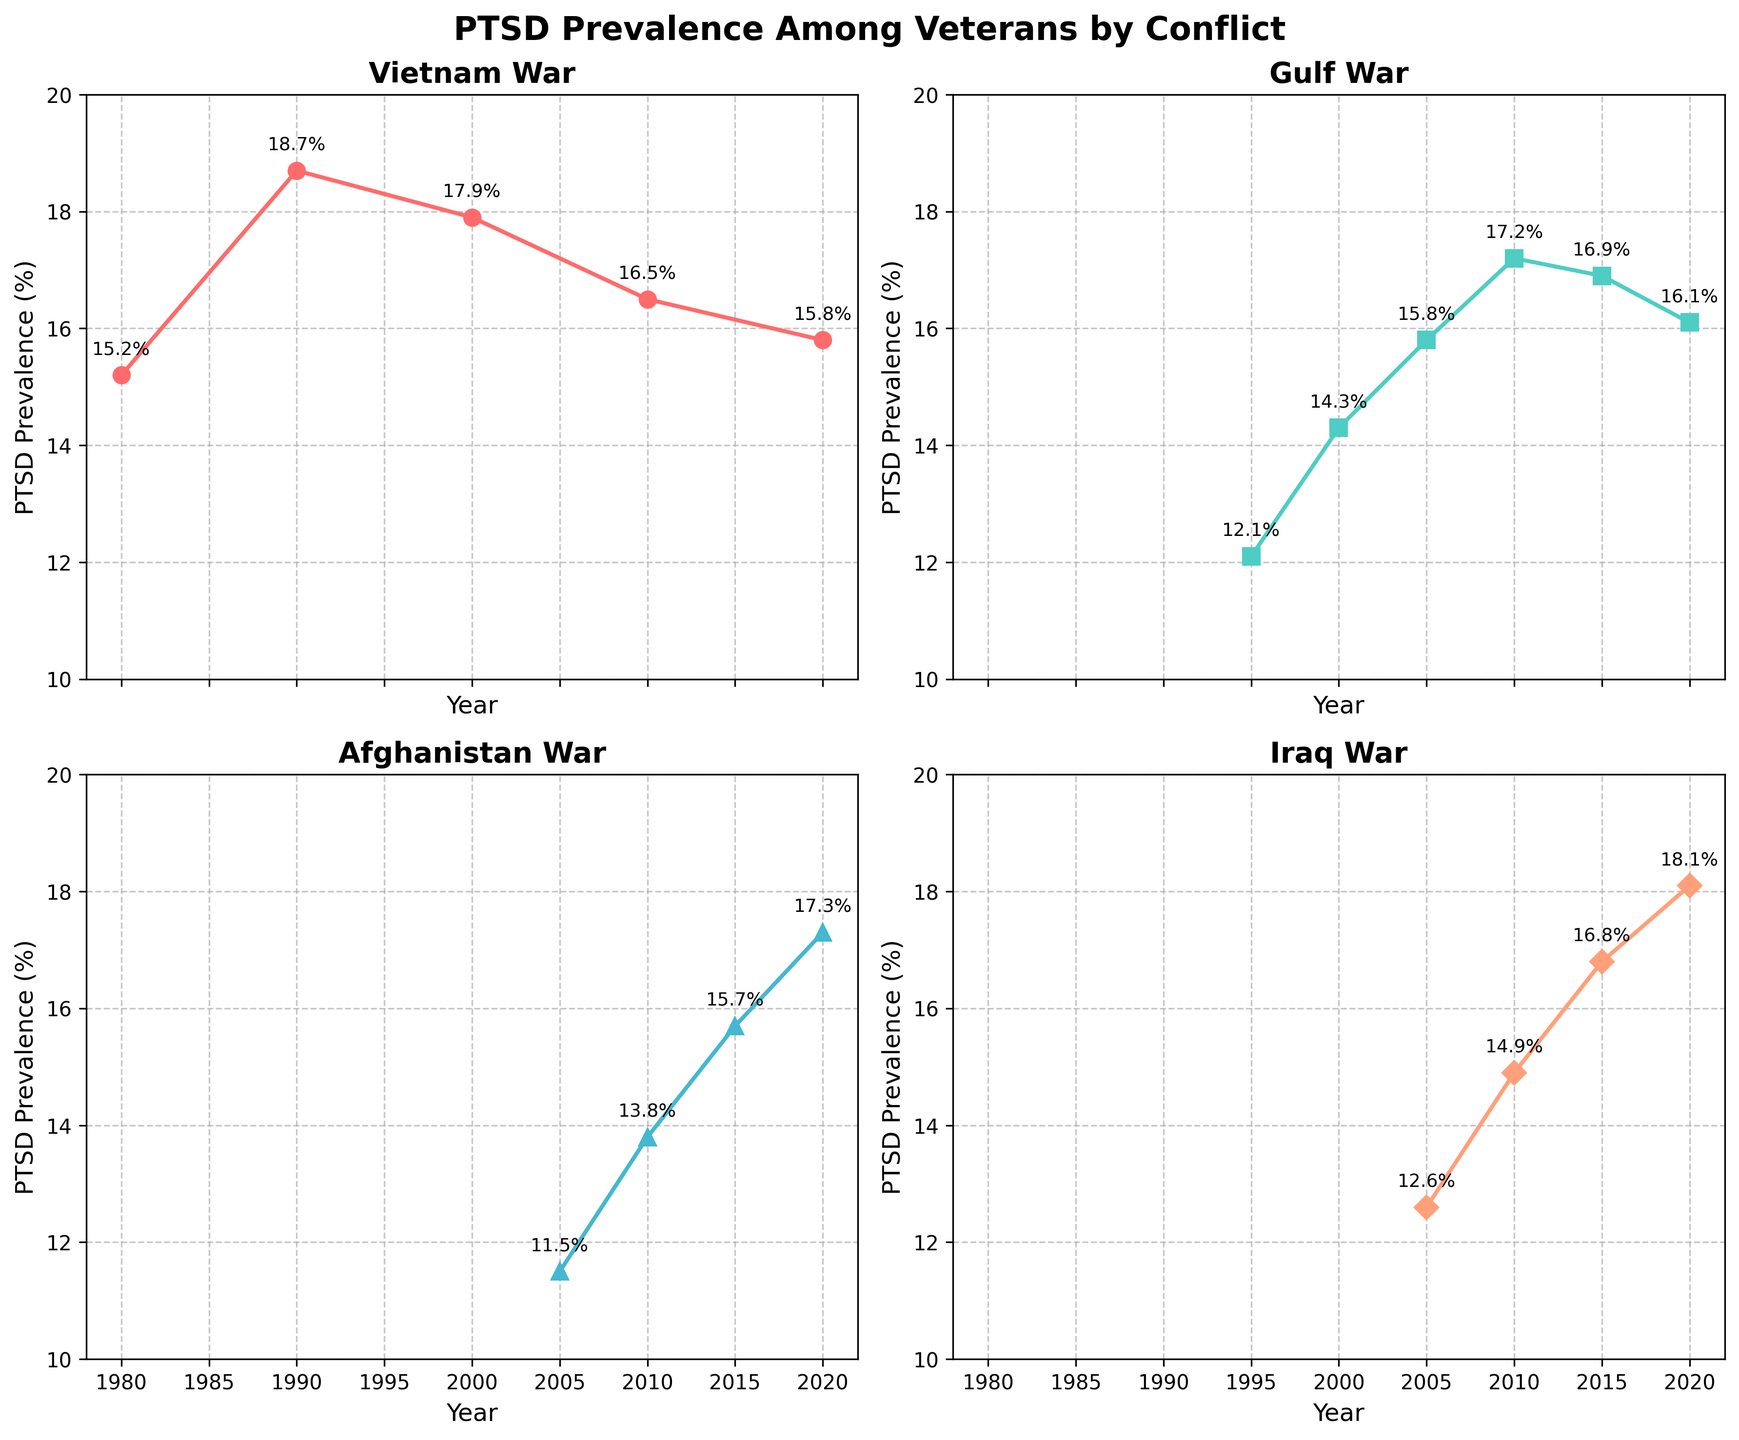What is the title of the figure? The title is found at the top center of the figure. It provides an overarching description of what the figure represents.
Answer: PTSD Prevalence Among Veterans by Conflict How many subplots are there in the figure? The figure is divided into multiple smaller sections, arranged in a grid form.
Answer: 4 What is the X-axis label in each subplot? The X-axis label is present at the bottom of each subplot, indicating what the horizontal axis represents.
Answer: Year What is the Y-axis label in each subplot? The Y-axis label is present on the left side of each subplot, indicating what the vertical axis represents.
Answer: PTSD Prevalence (%) What is the average PTSD prevalence for the Vietnam War conflict across all years? To find the average, add the PTSD prevalence reported for all five years under the Vietnam War and divide by the number of years. (15.2 + 18.7 + 17.9 + 16.5 + 15.8) / 5
Answer: 16.82% What is the total increase in PTSD prevalence for the Afghanistan War from 2005 to 2020? Find the difference between the PTSD prevalence in 2020 and 2005. 17.3 - 11.5
Answer: 5.8% Which conflict had the highest PTSD prevalence in 2020? Compare the PTSD prevalence data for each conflict in 2020 and identify the highest value.
Answer: Iraq War Which conflict saw the highest increase in PTSD prevalence over the years it was tracked? Compare the difference between the earliest and latest reported values for each conflict. Calculate the difference for Vietnam War, Gulf War, Afghanistan War, and Iraq War conflicts, respectively. The Iraq War shows the highest increase (18.1 - 12.6 = 5.5%).
Answer: Iraq War Which conflict has data points starting from the earliest year in the figure? Look at the starting year for each subplot and determine which one has the earliest start year.
Answer: Vietnam War Which conflict had the most fluctuation in PTSD prevalence over time? Identify which conflict shows the widest range between its highest and lowest values on its respective subplot. Vietnam War (18.7 - 15.2 = 3.5), Gulf War (17.2 - 12.1 = 5.1), Afghanistan War (17.3 - 11.5 = 5.8), Iraq War (18.1 - 12.6 = 5.5). Afghanistan War has the greatest range of fluctuation.
Answer: Afghanistan War 